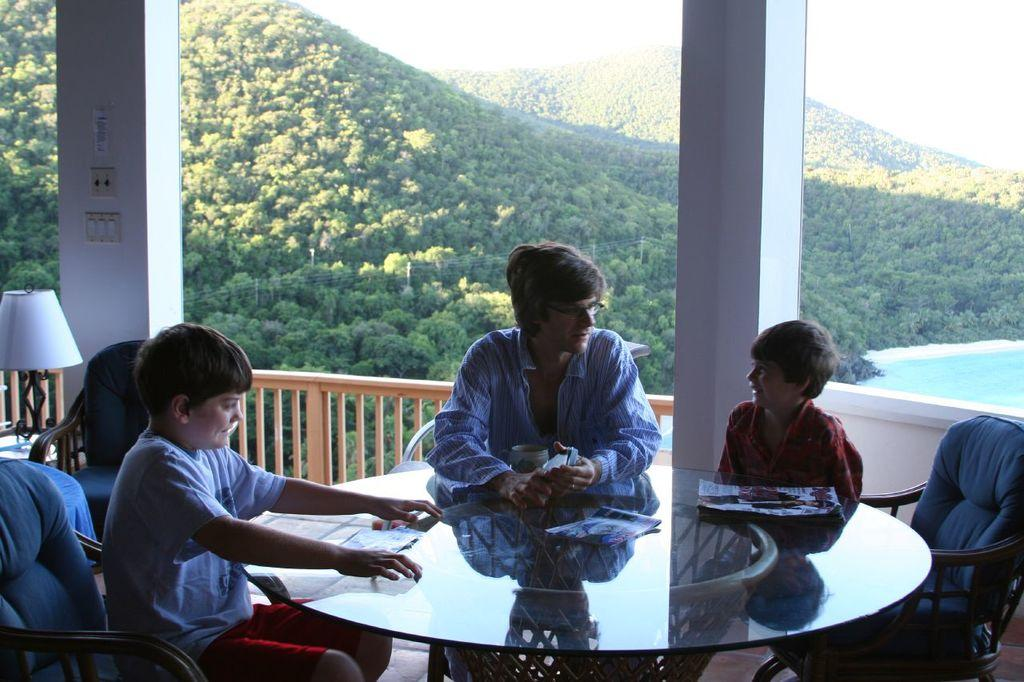How many children are in the image? There are two children in the image. Who else is present in the image besides the children? There is a person in the image. What are the children and person doing in the image? They are sitting on chairs around a table. What can be seen in the background of the image? Trees and water are visible in the background. What type of property does the maid own in the image? There is no maid or property present in the image. What town is visible in the background of the image? There is no town visible in the background; only trees and water are present. 